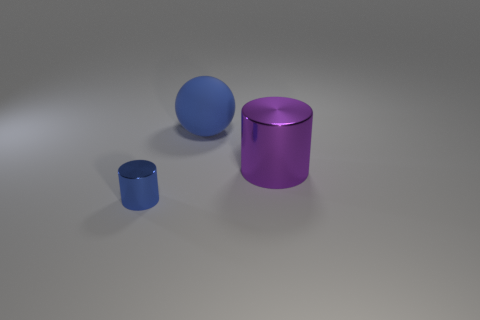Add 1 big yellow blocks. How many objects exist? 4 Subtract all spheres. How many objects are left? 2 Subtract all small gray rubber cubes. Subtract all purple things. How many objects are left? 2 Add 1 big cylinders. How many big cylinders are left? 2 Add 3 big rubber balls. How many big rubber balls exist? 4 Subtract 0 green cylinders. How many objects are left? 3 